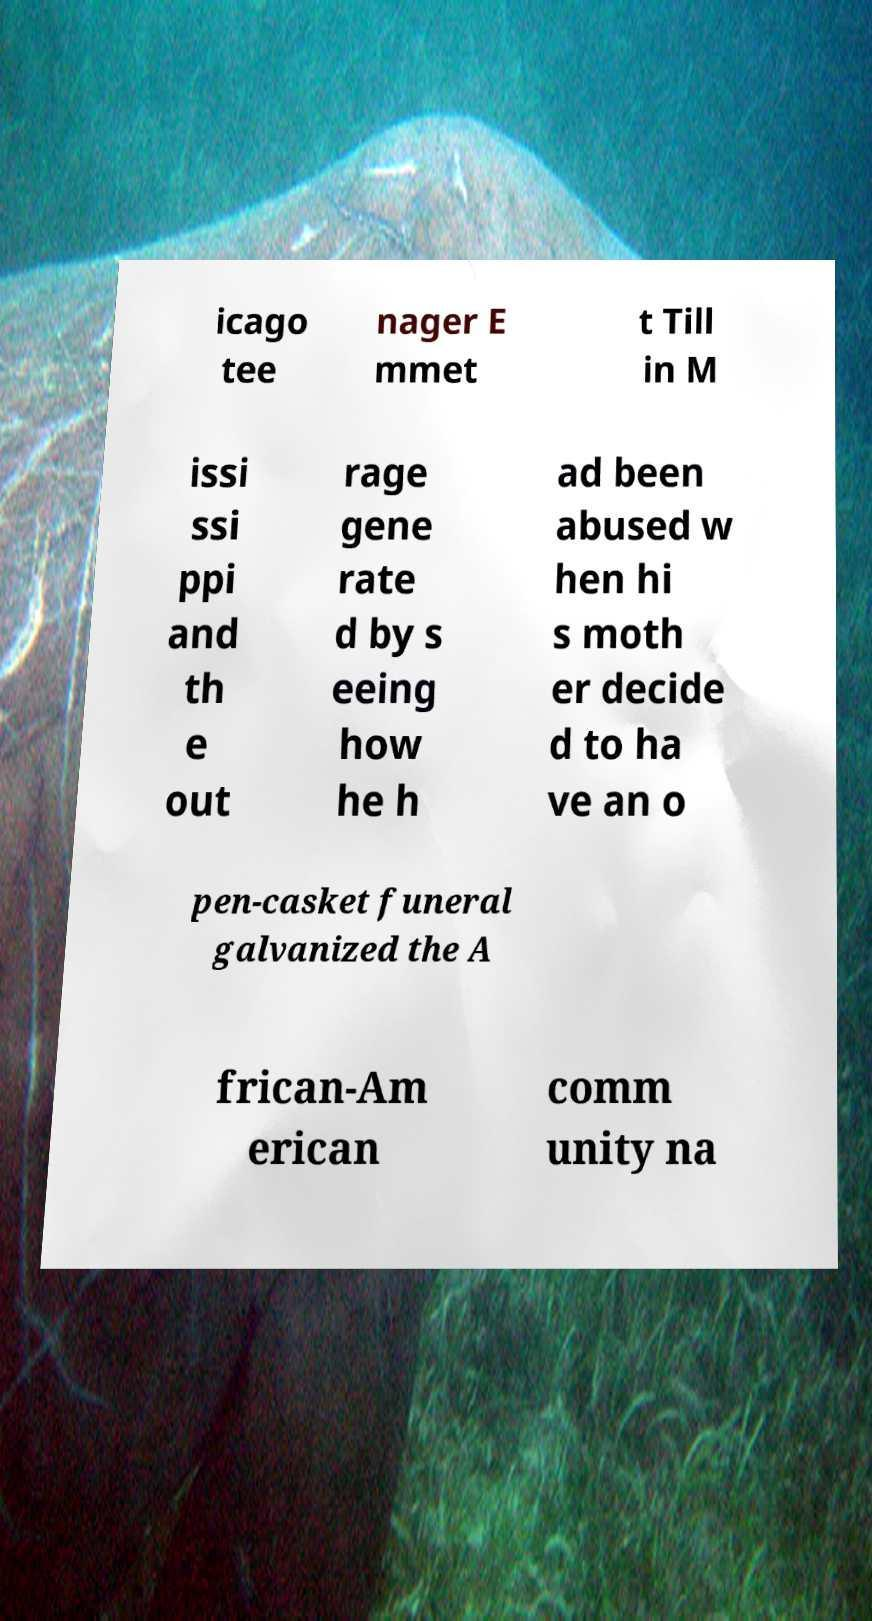Please identify and transcribe the text found in this image. icago tee nager E mmet t Till in M issi ssi ppi and th e out rage gene rate d by s eeing how he h ad been abused w hen hi s moth er decide d to ha ve an o pen-casket funeral galvanized the A frican-Am erican comm unity na 